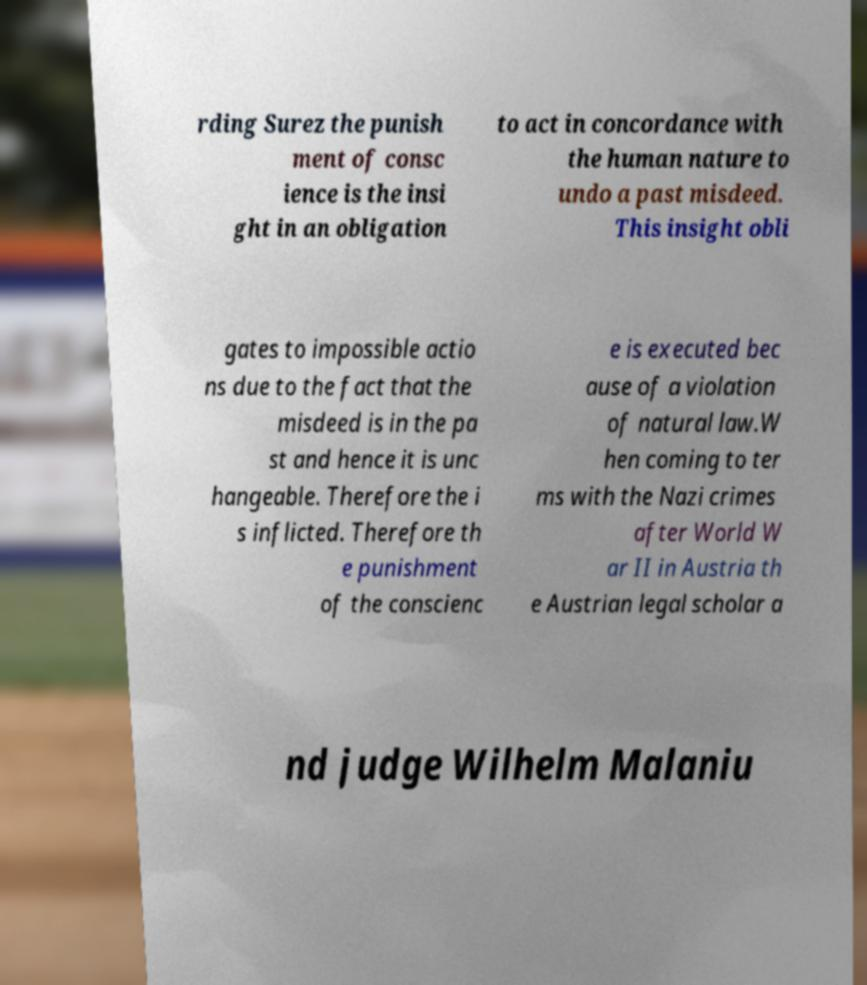There's text embedded in this image that I need extracted. Can you transcribe it verbatim? rding Surez the punish ment of consc ience is the insi ght in an obligation to act in concordance with the human nature to undo a past misdeed. This insight obli gates to impossible actio ns due to the fact that the misdeed is in the pa st and hence it is unc hangeable. Therefore the i s inflicted. Therefore th e punishment of the conscienc e is executed bec ause of a violation of natural law.W hen coming to ter ms with the Nazi crimes after World W ar II in Austria th e Austrian legal scholar a nd judge Wilhelm Malaniu 